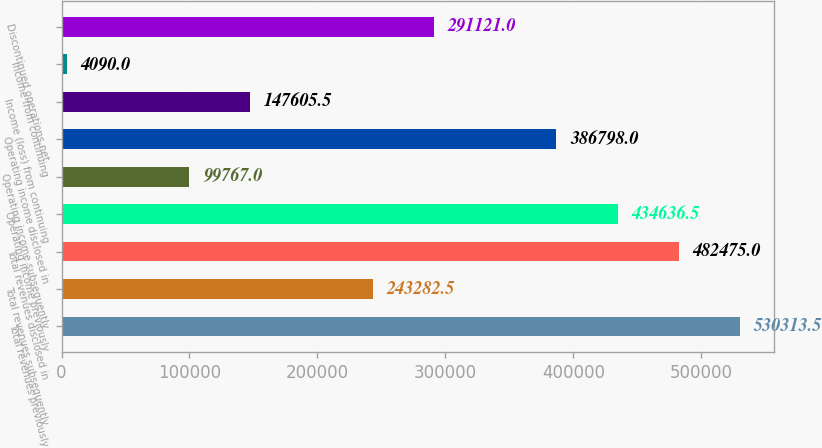Convert chart. <chart><loc_0><loc_0><loc_500><loc_500><bar_chart><fcel>Total revenues previously<fcel>Total revenues subsequently<fcel>Total revenues disclosed in<fcel>Operating income previously<fcel>Operating income subsequently<fcel>Operating income disclosed in<fcel>Income (loss) from continuing<fcel>Income from continuing<fcel>Discontinued operations net<nl><fcel>530314<fcel>243282<fcel>482475<fcel>434636<fcel>99767<fcel>386798<fcel>147606<fcel>4090<fcel>291121<nl></chart> 